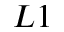<formula> <loc_0><loc_0><loc_500><loc_500>L 1</formula> 